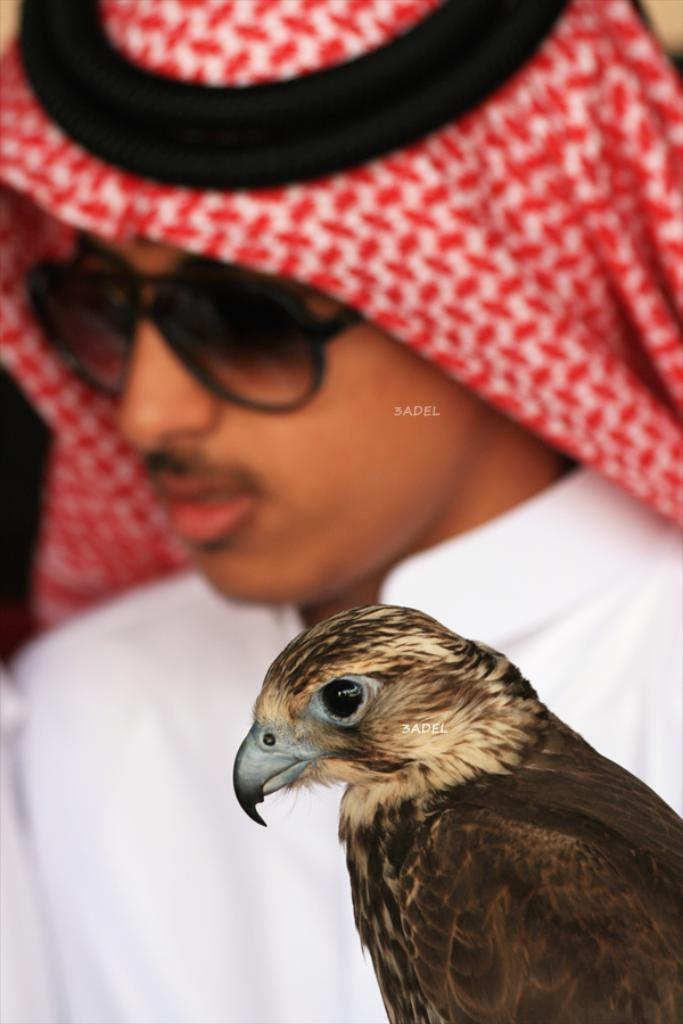What type of bird is in the image? There is a hawk in the image. Can you describe the setting of the image? There is a person in the background of the image. What type of twig is the hawk holding in its beak in the image? There is no twig visible in the image; the hawk is not holding anything in its beak. 